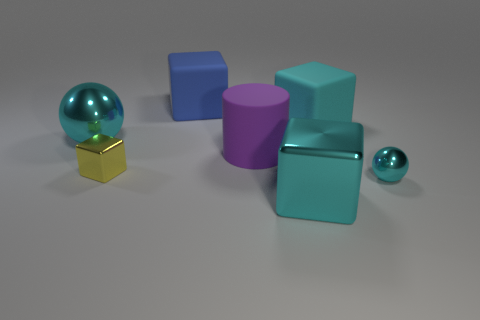What number of cyan metal things are there?
Keep it short and to the point. 3. Is the shape of the metal thing behind the small yellow shiny thing the same as  the big cyan matte thing?
Your answer should be compact. No. There is a blue object that is the same size as the cyan rubber thing; what material is it?
Provide a short and direct response. Rubber. Is there another tiny cyan ball that has the same material as the tiny cyan sphere?
Provide a short and direct response. No. Does the yellow object have the same shape as the big cyan object in front of the small ball?
Make the answer very short. Yes. What number of metal things are both behind the big purple cylinder and on the right side of the blue cube?
Give a very brief answer. 0. Is the material of the small cyan thing the same as the large cube to the left of the large purple matte thing?
Your answer should be very brief. No. Are there an equal number of large cyan blocks that are right of the large cyan rubber thing and large green shiny objects?
Make the answer very short. Yes. There is a large object that is on the right side of the cyan shiny block; what is its color?
Offer a terse response. Cyan. What number of other things are the same color as the small block?
Ensure brevity in your answer.  0. 